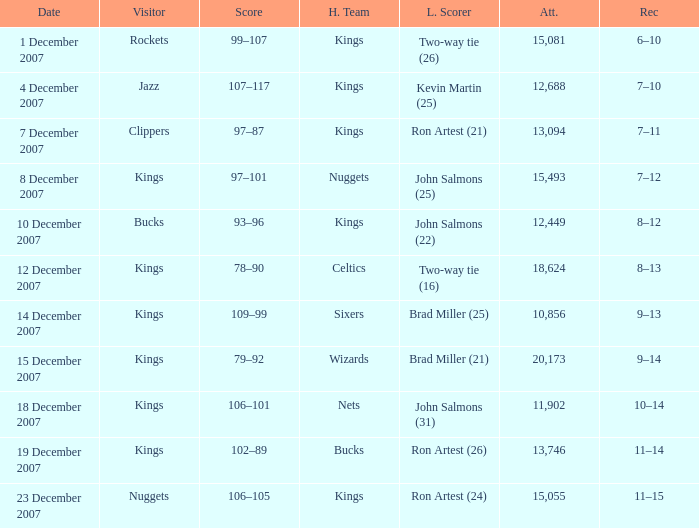What was the record of the game where the Rockets were the visiting team? 6–10. 